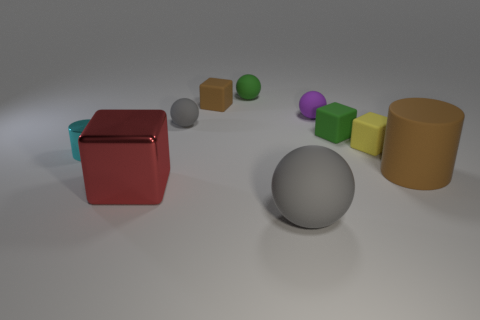Subtract all small brown blocks. How many blocks are left? 3 Add 8 gray matte balls. How many gray matte balls are left? 10 Add 8 purple spheres. How many purple spheres exist? 9 Subtract all brown blocks. How many blocks are left? 3 Subtract 2 gray spheres. How many objects are left? 8 Subtract all blocks. How many objects are left? 6 Subtract 2 cubes. How many cubes are left? 2 Subtract all purple cubes. Subtract all gray cylinders. How many cubes are left? 4 Subtract all yellow balls. How many brown cubes are left? 1 Subtract all tiny brown objects. Subtract all large matte objects. How many objects are left? 7 